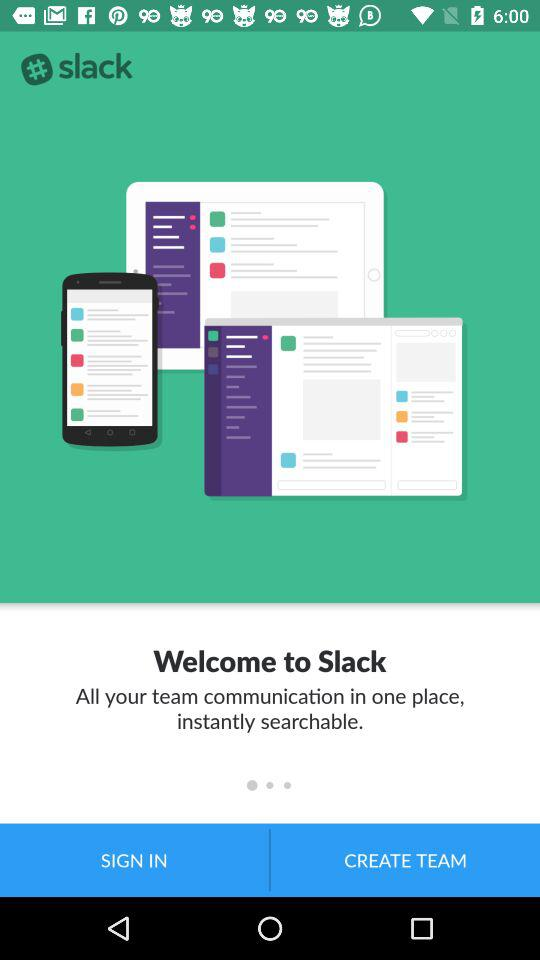What is the app's name? The app's name is "slack". 